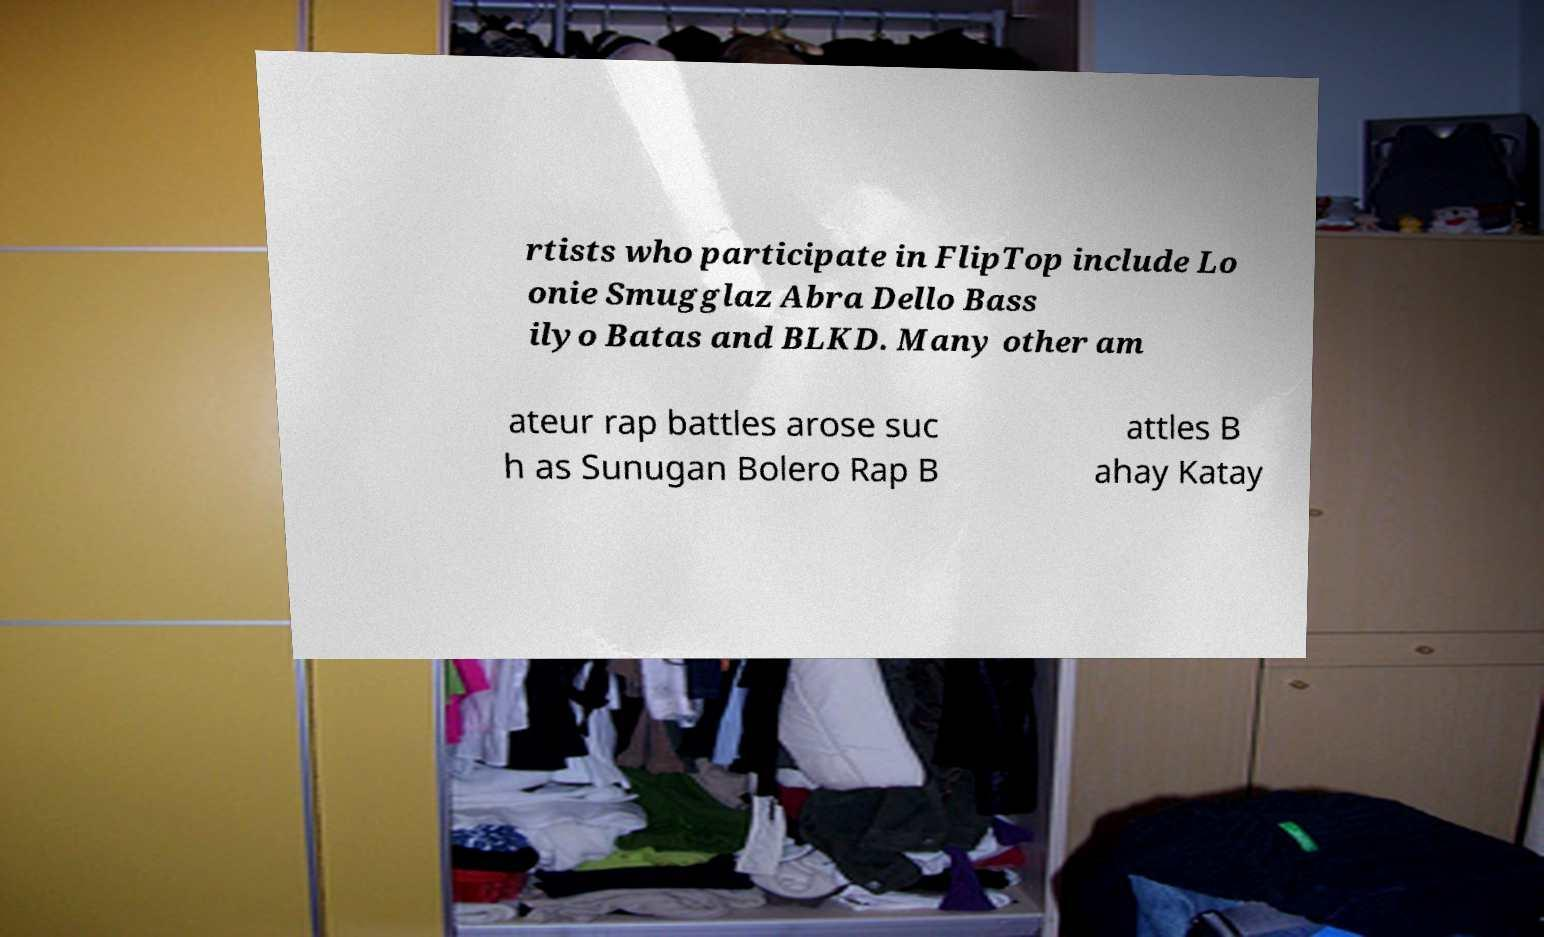What messages or text are displayed in this image? I need them in a readable, typed format. rtists who participate in FlipTop include Lo onie Smugglaz Abra Dello Bass ilyo Batas and BLKD. Many other am ateur rap battles arose suc h as Sunugan Bolero Rap B attles B ahay Katay 